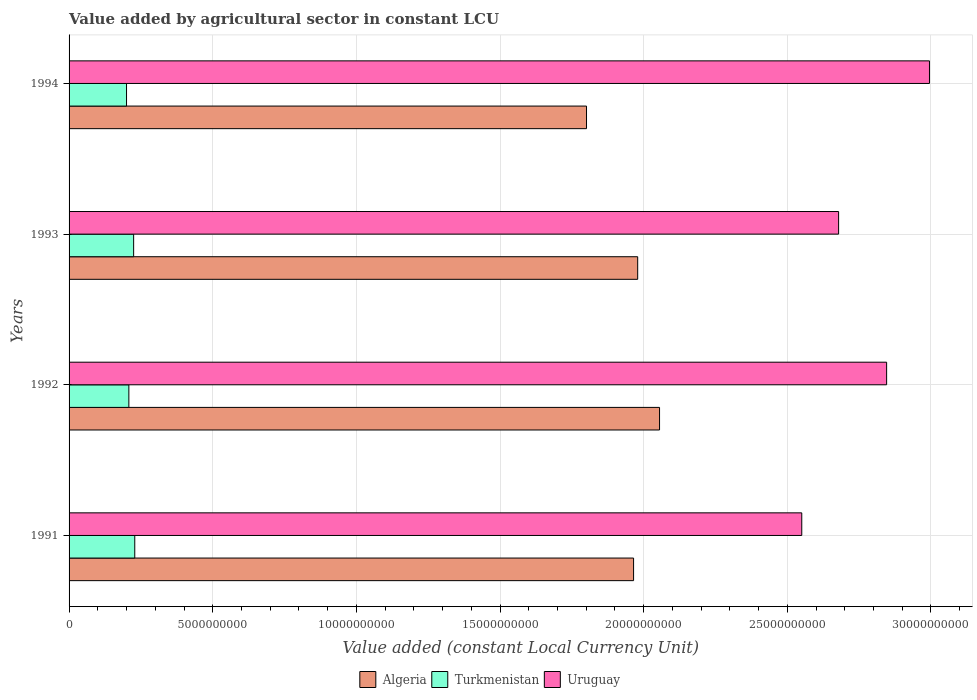How many different coloured bars are there?
Ensure brevity in your answer.  3. How many groups of bars are there?
Provide a short and direct response. 4. Are the number of bars per tick equal to the number of legend labels?
Ensure brevity in your answer.  Yes. Are the number of bars on each tick of the Y-axis equal?
Ensure brevity in your answer.  Yes. How many bars are there on the 3rd tick from the top?
Ensure brevity in your answer.  3. How many bars are there on the 4th tick from the bottom?
Give a very brief answer. 3. What is the label of the 3rd group of bars from the top?
Make the answer very short. 1992. What is the value added by agricultural sector in Turkmenistan in 1994?
Your response must be concise. 2.00e+09. Across all years, what is the maximum value added by agricultural sector in Algeria?
Make the answer very short. 2.06e+1. Across all years, what is the minimum value added by agricultural sector in Turkmenistan?
Keep it short and to the point. 2.00e+09. In which year was the value added by agricultural sector in Uruguay maximum?
Offer a very short reply. 1994. What is the total value added by agricultural sector in Algeria in the graph?
Your answer should be compact. 7.80e+1. What is the difference between the value added by agricultural sector in Turkmenistan in 1991 and that in 1992?
Your answer should be very brief. 2.06e+08. What is the difference between the value added by agricultural sector in Turkmenistan in 1994 and the value added by agricultural sector in Uruguay in 1993?
Make the answer very short. -2.48e+1. What is the average value added by agricultural sector in Algeria per year?
Provide a succinct answer. 1.95e+1. In the year 1994, what is the difference between the value added by agricultural sector in Algeria and value added by agricultural sector in Turkmenistan?
Ensure brevity in your answer.  1.60e+1. What is the ratio of the value added by agricultural sector in Uruguay in 1993 to that in 1994?
Provide a short and direct response. 0.89. Is the difference between the value added by agricultural sector in Algeria in 1991 and 1992 greater than the difference between the value added by agricultural sector in Turkmenistan in 1991 and 1992?
Your answer should be compact. No. What is the difference between the highest and the second highest value added by agricultural sector in Uruguay?
Provide a succinct answer. 1.49e+09. What is the difference between the highest and the lowest value added by agricultural sector in Uruguay?
Your answer should be very brief. 4.45e+09. In how many years, is the value added by agricultural sector in Turkmenistan greater than the average value added by agricultural sector in Turkmenistan taken over all years?
Your answer should be very brief. 2. Is the sum of the value added by agricultural sector in Uruguay in 1993 and 1994 greater than the maximum value added by agricultural sector in Algeria across all years?
Ensure brevity in your answer.  Yes. What does the 3rd bar from the top in 1991 represents?
Offer a very short reply. Algeria. What does the 1st bar from the bottom in 1991 represents?
Make the answer very short. Algeria. Is it the case that in every year, the sum of the value added by agricultural sector in Turkmenistan and value added by agricultural sector in Algeria is greater than the value added by agricultural sector in Uruguay?
Offer a very short reply. No. Are all the bars in the graph horizontal?
Your answer should be very brief. Yes. What is the difference between two consecutive major ticks on the X-axis?
Your answer should be very brief. 5.00e+09. Does the graph contain any zero values?
Offer a terse response. No. Does the graph contain grids?
Offer a terse response. Yes. Where does the legend appear in the graph?
Make the answer very short. Bottom center. How are the legend labels stacked?
Give a very brief answer. Horizontal. What is the title of the graph?
Offer a very short reply. Value added by agricultural sector in constant LCU. What is the label or title of the X-axis?
Offer a terse response. Value added (constant Local Currency Unit). What is the label or title of the Y-axis?
Keep it short and to the point. Years. What is the Value added (constant Local Currency Unit) in Algeria in 1991?
Make the answer very short. 1.96e+1. What is the Value added (constant Local Currency Unit) in Turkmenistan in 1991?
Provide a succinct answer. 2.29e+09. What is the Value added (constant Local Currency Unit) in Uruguay in 1991?
Ensure brevity in your answer.  2.55e+1. What is the Value added (constant Local Currency Unit) of Algeria in 1992?
Your answer should be compact. 2.06e+1. What is the Value added (constant Local Currency Unit) in Turkmenistan in 1992?
Your answer should be compact. 2.08e+09. What is the Value added (constant Local Currency Unit) of Uruguay in 1992?
Provide a short and direct response. 2.85e+1. What is the Value added (constant Local Currency Unit) of Algeria in 1993?
Your answer should be very brief. 1.98e+1. What is the Value added (constant Local Currency Unit) of Turkmenistan in 1993?
Your answer should be compact. 2.25e+09. What is the Value added (constant Local Currency Unit) in Uruguay in 1993?
Your answer should be compact. 2.68e+1. What is the Value added (constant Local Currency Unit) in Algeria in 1994?
Provide a succinct answer. 1.80e+1. What is the Value added (constant Local Currency Unit) in Turkmenistan in 1994?
Your answer should be compact. 2.00e+09. What is the Value added (constant Local Currency Unit) of Uruguay in 1994?
Keep it short and to the point. 2.99e+1. Across all years, what is the maximum Value added (constant Local Currency Unit) of Algeria?
Give a very brief answer. 2.06e+1. Across all years, what is the maximum Value added (constant Local Currency Unit) of Turkmenistan?
Offer a terse response. 2.29e+09. Across all years, what is the maximum Value added (constant Local Currency Unit) of Uruguay?
Your response must be concise. 2.99e+1. Across all years, what is the minimum Value added (constant Local Currency Unit) of Algeria?
Make the answer very short. 1.80e+1. Across all years, what is the minimum Value added (constant Local Currency Unit) of Turkmenistan?
Your response must be concise. 2.00e+09. Across all years, what is the minimum Value added (constant Local Currency Unit) of Uruguay?
Your answer should be very brief. 2.55e+1. What is the total Value added (constant Local Currency Unit) in Algeria in the graph?
Keep it short and to the point. 7.80e+1. What is the total Value added (constant Local Currency Unit) in Turkmenistan in the graph?
Ensure brevity in your answer.  8.62e+09. What is the total Value added (constant Local Currency Unit) of Uruguay in the graph?
Your response must be concise. 1.11e+11. What is the difference between the Value added (constant Local Currency Unit) in Algeria in 1991 and that in 1992?
Offer a terse response. -9.04e+08. What is the difference between the Value added (constant Local Currency Unit) of Turkmenistan in 1991 and that in 1992?
Your response must be concise. 2.06e+08. What is the difference between the Value added (constant Local Currency Unit) of Uruguay in 1991 and that in 1992?
Provide a short and direct response. -2.95e+09. What is the difference between the Value added (constant Local Currency Unit) in Algeria in 1991 and that in 1993?
Offer a very short reply. -1.43e+08. What is the difference between the Value added (constant Local Currency Unit) in Turkmenistan in 1991 and that in 1993?
Offer a terse response. 3.93e+07. What is the difference between the Value added (constant Local Currency Unit) in Uruguay in 1991 and that in 1993?
Provide a succinct answer. -1.28e+09. What is the difference between the Value added (constant Local Currency Unit) in Algeria in 1991 and that in 1994?
Offer a very short reply. 1.64e+09. What is the difference between the Value added (constant Local Currency Unit) of Turkmenistan in 1991 and that in 1994?
Offer a very short reply. 2.87e+08. What is the difference between the Value added (constant Local Currency Unit) in Uruguay in 1991 and that in 1994?
Give a very brief answer. -4.45e+09. What is the difference between the Value added (constant Local Currency Unit) of Algeria in 1992 and that in 1993?
Your response must be concise. 7.60e+08. What is the difference between the Value added (constant Local Currency Unit) in Turkmenistan in 1992 and that in 1993?
Offer a very short reply. -1.66e+08. What is the difference between the Value added (constant Local Currency Unit) of Uruguay in 1992 and that in 1993?
Give a very brief answer. 1.67e+09. What is the difference between the Value added (constant Local Currency Unit) of Algeria in 1992 and that in 1994?
Your answer should be compact. 2.54e+09. What is the difference between the Value added (constant Local Currency Unit) in Turkmenistan in 1992 and that in 1994?
Offer a very short reply. 8.07e+07. What is the difference between the Value added (constant Local Currency Unit) of Uruguay in 1992 and that in 1994?
Ensure brevity in your answer.  -1.49e+09. What is the difference between the Value added (constant Local Currency Unit) in Algeria in 1993 and that in 1994?
Keep it short and to the point. 1.78e+09. What is the difference between the Value added (constant Local Currency Unit) in Turkmenistan in 1993 and that in 1994?
Make the answer very short. 2.47e+08. What is the difference between the Value added (constant Local Currency Unit) in Uruguay in 1993 and that in 1994?
Give a very brief answer. -3.16e+09. What is the difference between the Value added (constant Local Currency Unit) of Algeria in 1991 and the Value added (constant Local Currency Unit) of Turkmenistan in 1992?
Provide a succinct answer. 1.76e+1. What is the difference between the Value added (constant Local Currency Unit) of Algeria in 1991 and the Value added (constant Local Currency Unit) of Uruguay in 1992?
Your answer should be compact. -8.81e+09. What is the difference between the Value added (constant Local Currency Unit) of Turkmenistan in 1991 and the Value added (constant Local Currency Unit) of Uruguay in 1992?
Your response must be concise. -2.62e+1. What is the difference between the Value added (constant Local Currency Unit) of Algeria in 1991 and the Value added (constant Local Currency Unit) of Turkmenistan in 1993?
Offer a terse response. 1.74e+1. What is the difference between the Value added (constant Local Currency Unit) of Algeria in 1991 and the Value added (constant Local Currency Unit) of Uruguay in 1993?
Offer a very short reply. -7.14e+09. What is the difference between the Value added (constant Local Currency Unit) of Turkmenistan in 1991 and the Value added (constant Local Currency Unit) of Uruguay in 1993?
Keep it short and to the point. -2.45e+1. What is the difference between the Value added (constant Local Currency Unit) in Algeria in 1991 and the Value added (constant Local Currency Unit) in Turkmenistan in 1994?
Provide a succinct answer. 1.76e+1. What is the difference between the Value added (constant Local Currency Unit) of Algeria in 1991 and the Value added (constant Local Currency Unit) of Uruguay in 1994?
Provide a short and direct response. -1.03e+1. What is the difference between the Value added (constant Local Currency Unit) of Turkmenistan in 1991 and the Value added (constant Local Currency Unit) of Uruguay in 1994?
Make the answer very short. -2.77e+1. What is the difference between the Value added (constant Local Currency Unit) of Algeria in 1992 and the Value added (constant Local Currency Unit) of Turkmenistan in 1993?
Provide a succinct answer. 1.83e+1. What is the difference between the Value added (constant Local Currency Unit) in Algeria in 1992 and the Value added (constant Local Currency Unit) in Uruguay in 1993?
Give a very brief answer. -6.23e+09. What is the difference between the Value added (constant Local Currency Unit) in Turkmenistan in 1992 and the Value added (constant Local Currency Unit) in Uruguay in 1993?
Make the answer very short. -2.47e+1. What is the difference between the Value added (constant Local Currency Unit) in Algeria in 1992 and the Value added (constant Local Currency Unit) in Turkmenistan in 1994?
Keep it short and to the point. 1.86e+1. What is the difference between the Value added (constant Local Currency Unit) in Algeria in 1992 and the Value added (constant Local Currency Unit) in Uruguay in 1994?
Your answer should be very brief. -9.40e+09. What is the difference between the Value added (constant Local Currency Unit) in Turkmenistan in 1992 and the Value added (constant Local Currency Unit) in Uruguay in 1994?
Your answer should be compact. -2.79e+1. What is the difference between the Value added (constant Local Currency Unit) in Algeria in 1993 and the Value added (constant Local Currency Unit) in Turkmenistan in 1994?
Keep it short and to the point. 1.78e+1. What is the difference between the Value added (constant Local Currency Unit) in Algeria in 1993 and the Value added (constant Local Currency Unit) in Uruguay in 1994?
Offer a terse response. -1.02e+1. What is the difference between the Value added (constant Local Currency Unit) in Turkmenistan in 1993 and the Value added (constant Local Currency Unit) in Uruguay in 1994?
Offer a terse response. -2.77e+1. What is the average Value added (constant Local Currency Unit) in Algeria per year?
Make the answer very short. 1.95e+1. What is the average Value added (constant Local Currency Unit) of Turkmenistan per year?
Offer a terse response. 2.15e+09. What is the average Value added (constant Local Currency Unit) of Uruguay per year?
Offer a terse response. 2.77e+1. In the year 1991, what is the difference between the Value added (constant Local Currency Unit) in Algeria and Value added (constant Local Currency Unit) in Turkmenistan?
Your answer should be very brief. 1.74e+1. In the year 1991, what is the difference between the Value added (constant Local Currency Unit) of Algeria and Value added (constant Local Currency Unit) of Uruguay?
Your response must be concise. -5.85e+09. In the year 1991, what is the difference between the Value added (constant Local Currency Unit) in Turkmenistan and Value added (constant Local Currency Unit) in Uruguay?
Your answer should be compact. -2.32e+1. In the year 1992, what is the difference between the Value added (constant Local Currency Unit) in Algeria and Value added (constant Local Currency Unit) in Turkmenistan?
Keep it short and to the point. 1.85e+1. In the year 1992, what is the difference between the Value added (constant Local Currency Unit) in Algeria and Value added (constant Local Currency Unit) in Uruguay?
Your response must be concise. -7.90e+09. In the year 1992, what is the difference between the Value added (constant Local Currency Unit) of Turkmenistan and Value added (constant Local Currency Unit) of Uruguay?
Provide a succinct answer. -2.64e+1. In the year 1993, what is the difference between the Value added (constant Local Currency Unit) in Algeria and Value added (constant Local Currency Unit) in Turkmenistan?
Ensure brevity in your answer.  1.75e+1. In the year 1993, what is the difference between the Value added (constant Local Currency Unit) in Algeria and Value added (constant Local Currency Unit) in Uruguay?
Keep it short and to the point. -6.99e+09. In the year 1993, what is the difference between the Value added (constant Local Currency Unit) in Turkmenistan and Value added (constant Local Currency Unit) in Uruguay?
Provide a short and direct response. -2.45e+1. In the year 1994, what is the difference between the Value added (constant Local Currency Unit) in Algeria and Value added (constant Local Currency Unit) in Turkmenistan?
Your answer should be very brief. 1.60e+1. In the year 1994, what is the difference between the Value added (constant Local Currency Unit) of Algeria and Value added (constant Local Currency Unit) of Uruguay?
Offer a terse response. -1.19e+1. In the year 1994, what is the difference between the Value added (constant Local Currency Unit) of Turkmenistan and Value added (constant Local Currency Unit) of Uruguay?
Make the answer very short. -2.79e+1. What is the ratio of the Value added (constant Local Currency Unit) in Algeria in 1991 to that in 1992?
Offer a very short reply. 0.96. What is the ratio of the Value added (constant Local Currency Unit) of Turkmenistan in 1991 to that in 1992?
Ensure brevity in your answer.  1.1. What is the ratio of the Value added (constant Local Currency Unit) in Uruguay in 1991 to that in 1992?
Ensure brevity in your answer.  0.9. What is the ratio of the Value added (constant Local Currency Unit) of Algeria in 1991 to that in 1993?
Offer a very short reply. 0.99. What is the ratio of the Value added (constant Local Currency Unit) of Turkmenistan in 1991 to that in 1993?
Make the answer very short. 1.02. What is the ratio of the Value added (constant Local Currency Unit) in Uruguay in 1991 to that in 1993?
Your answer should be compact. 0.95. What is the ratio of the Value added (constant Local Currency Unit) of Turkmenistan in 1991 to that in 1994?
Your answer should be very brief. 1.14. What is the ratio of the Value added (constant Local Currency Unit) of Uruguay in 1991 to that in 1994?
Your response must be concise. 0.85. What is the ratio of the Value added (constant Local Currency Unit) in Algeria in 1992 to that in 1993?
Make the answer very short. 1.04. What is the ratio of the Value added (constant Local Currency Unit) in Turkmenistan in 1992 to that in 1993?
Provide a succinct answer. 0.93. What is the ratio of the Value added (constant Local Currency Unit) of Uruguay in 1992 to that in 1993?
Provide a short and direct response. 1.06. What is the ratio of the Value added (constant Local Currency Unit) of Algeria in 1992 to that in 1994?
Make the answer very short. 1.14. What is the ratio of the Value added (constant Local Currency Unit) of Turkmenistan in 1992 to that in 1994?
Provide a short and direct response. 1.04. What is the ratio of the Value added (constant Local Currency Unit) of Uruguay in 1992 to that in 1994?
Provide a short and direct response. 0.95. What is the ratio of the Value added (constant Local Currency Unit) in Algeria in 1993 to that in 1994?
Make the answer very short. 1.1. What is the ratio of the Value added (constant Local Currency Unit) in Turkmenistan in 1993 to that in 1994?
Offer a very short reply. 1.12. What is the ratio of the Value added (constant Local Currency Unit) of Uruguay in 1993 to that in 1994?
Your answer should be compact. 0.89. What is the difference between the highest and the second highest Value added (constant Local Currency Unit) in Algeria?
Provide a succinct answer. 7.60e+08. What is the difference between the highest and the second highest Value added (constant Local Currency Unit) of Turkmenistan?
Provide a short and direct response. 3.93e+07. What is the difference between the highest and the second highest Value added (constant Local Currency Unit) in Uruguay?
Provide a succinct answer. 1.49e+09. What is the difference between the highest and the lowest Value added (constant Local Currency Unit) in Algeria?
Provide a succinct answer. 2.54e+09. What is the difference between the highest and the lowest Value added (constant Local Currency Unit) of Turkmenistan?
Provide a succinct answer. 2.87e+08. What is the difference between the highest and the lowest Value added (constant Local Currency Unit) in Uruguay?
Ensure brevity in your answer.  4.45e+09. 